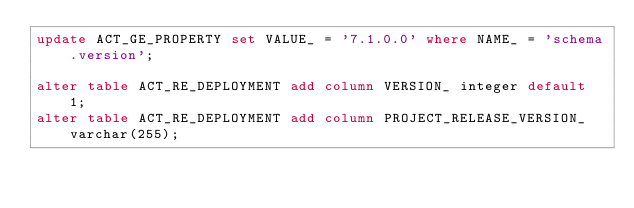Convert code to text. <code><loc_0><loc_0><loc_500><loc_500><_SQL_>update ACT_GE_PROPERTY set VALUE_ = '7.1.0.0' where NAME_ = 'schema.version';

alter table ACT_RE_DEPLOYMENT add column VERSION_ integer default 1;
alter table ACT_RE_DEPLOYMENT add column PROJECT_RELEASE_VERSION_ varchar(255);
</code> 